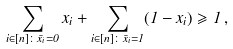<formula> <loc_0><loc_0><loc_500><loc_500>\sum _ { i \in [ n ] \colon \bar { x } _ { i } = 0 } x _ { i } + \sum _ { i \in [ n ] \colon \bar { x } _ { i } = 1 } ( 1 - x _ { i } ) \geqslant 1 \, ,</formula> 